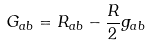Convert formula to latex. <formula><loc_0><loc_0><loc_500><loc_500>G _ { a b } = R _ { a b } - \frac { R } { 2 } g _ { a b }</formula> 